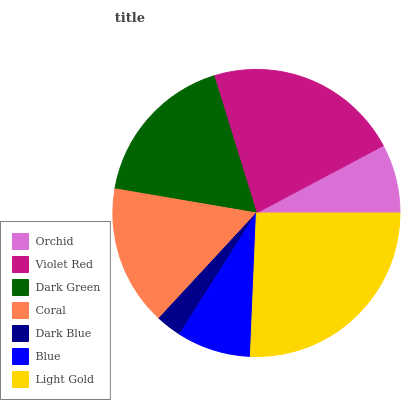Is Dark Blue the minimum?
Answer yes or no. Yes. Is Light Gold the maximum?
Answer yes or no. Yes. Is Violet Red the minimum?
Answer yes or no. No. Is Violet Red the maximum?
Answer yes or no. No. Is Violet Red greater than Orchid?
Answer yes or no. Yes. Is Orchid less than Violet Red?
Answer yes or no. Yes. Is Orchid greater than Violet Red?
Answer yes or no. No. Is Violet Red less than Orchid?
Answer yes or no. No. Is Coral the high median?
Answer yes or no. Yes. Is Coral the low median?
Answer yes or no. Yes. Is Dark Blue the high median?
Answer yes or no. No. Is Light Gold the low median?
Answer yes or no. No. 